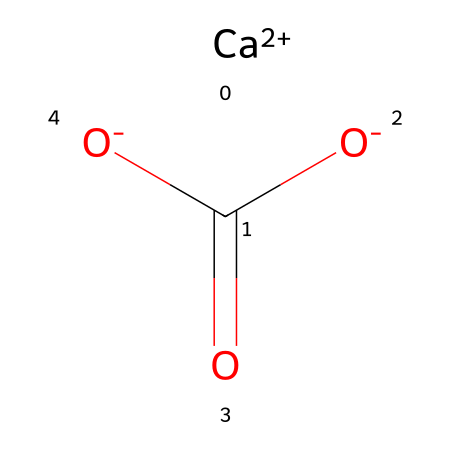What is the chemical name of the compound represented? The structure represents calcium carbonate, which is indicated by the presence of calcium ions (Ca) and the carbonate group (CO3).
Answer: calcium carbonate How many oxygen atoms are present in the chemical? By analyzing the carbonate group, we can see it contains three oxygen atoms connected to a single carbon atom.
Answer: 3 What is the oxidation state of calcium in this compound? Calcium is shown as Ca+2 in the SMILES representation, indicating it has a +2 oxidation state.
Answer: +2 What type of bonding is involved in this chemical structure? The presence of a metal cation (Ca+2) and an anion (carbonate) suggests an ionic bond formation between these two components.
Answer: ionic What is the primary use of calcium carbonate in ceramics? Calcium carbonate is primarily used as a flux in ceramic materials, which helps to lower the melting temperature during the firing process.
Answer: flux What indicates that this is a mineral compound? The compound is derived from natural sources (limestone) and its chemical structure reflects a common and stable mineral form, characteristic of inorganic minerals.
Answer: mineral What is the molecular formula implied by the SMILES notation? The SMILES indicates one calcium atom, one carbon atom, and three oxygen atoms, which translate to the molecular formula CaCO3.
Answer: CaCO3 